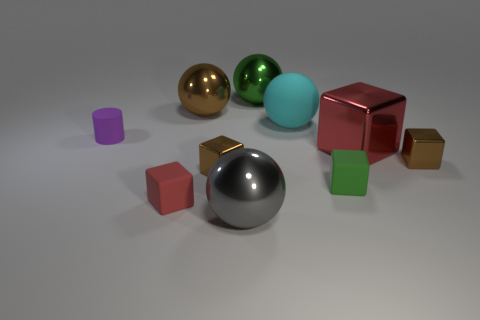Subtract all large red blocks. How many blocks are left? 4 Subtract all blue blocks. Subtract all red cylinders. How many blocks are left? 5 Subtract all cylinders. How many objects are left? 9 Subtract 0 yellow balls. How many objects are left? 10 Subtract all purple metallic objects. Subtract all tiny red matte objects. How many objects are left? 9 Add 7 large green spheres. How many large green spheres are left? 8 Add 4 red rubber objects. How many red rubber objects exist? 5 